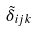<formula> <loc_0><loc_0><loc_500><loc_500>\tilde { \delta } _ { i j k }</formula> 